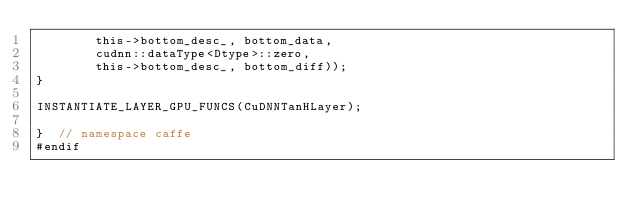<code> <loc_0><loc_0><loc_500><loc_500><_Cuda_>        this->bottom_desc_, bottom_data,
        cudnn::dataType<Dtype>::zero,
        this->bottom_desc_, bottom_diff));
}

INSTANTIATE_LAYER_GPU_FUNCS(CuDNNTanHLayer);

}  // namespace caffe
#endif
</code> 